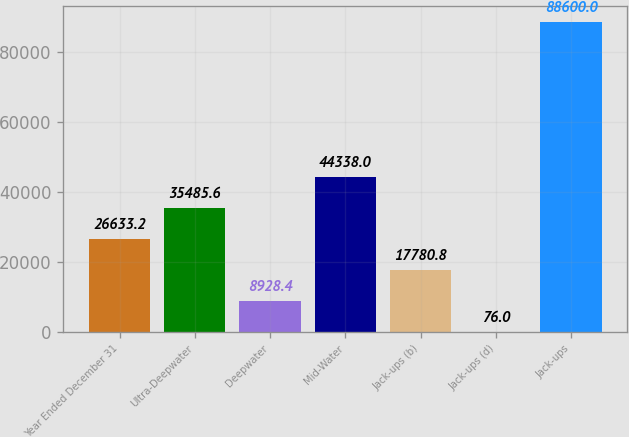Convert chart to OTSL. <chart><loc_0><loc_0><loc_500><loc_500><bar_chart><fcel>Year Ended December 31<fcel>Ultra-Deepwater<fcel>Deepwater<fcel>Mid-Water<fcel>Jack-ups (b)<fcel>Jack-ups (d)<fcel>Jack-ups<nl><fcel>26633.2<fcel>35485.6<fcel>8928.4<fcel>44338<fcel>17780.8<fcel>76<fcel>88600<nl></chart> 